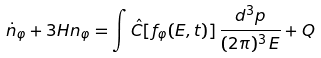Convert formula to latex. <formula><loc_0><loc_0><loc_500><loc_500>\dot { n } _ { \varphi } + 3 H n _ { \varphi } = \int \hat { C } [ f _ { \varphi } ( E , t ) ] \, \frac { d ^ { 3 } p } { ( 2 \pi ) ^ { 3 } \, E } + Q</formula> 